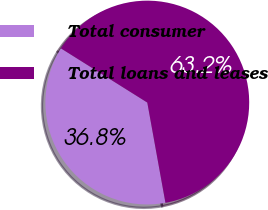<chart> <loc_0><loc_0><loc_500><loc_500><pie_chart><fcel>Total consumer<fcel>Total loans and leases<nl><fcel>36.77%<fcel>63.23%<nl></chart> 